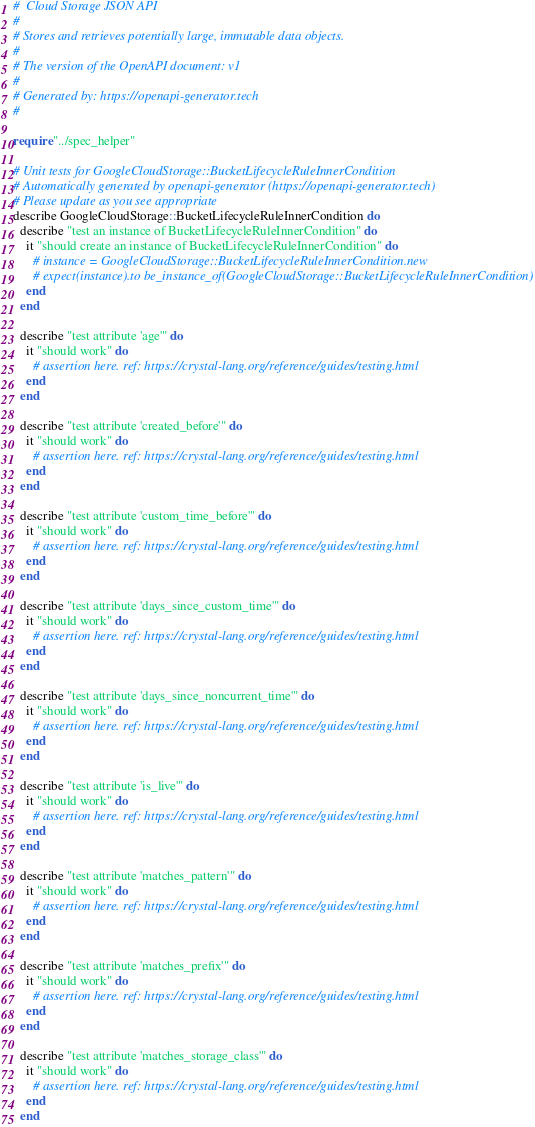Convert code to text. <code><loc_0><loc_0><loc_500><loc_500><_Crystal_>#  Cloud Storage JSON API
#
# Stores and retrieves potentially large, immutable data objects.
#
# The version of the OpenAPI document: v1
#
# Generated by: https://openapi-generator.tech
#

require "../spec_helper"

# Unit tests for GoogleCloudStorage::BucketLifecycleRuleInnerCondition
# Automatically generated by openapi-generator (https://openapi-generator.tech)
# Please update as you see appropriate
describe GoogleCloudStorage::BucketLifecycleRuleInnerCondition do
  describe "test an instance of BucketLifecycleRuleInnerCondition" do
    it "should create an instance of BucketLifecycleRuleInnerCondition" do
      # instance = GoogleCloudStorage::BucketLifecycleRuleInnerCondition.new
      # expect(instance).to be_instance_of(GoogleCloudStorage::BucketLifecycleRuleInnerCondition)
    end
  end

  describe "test attribute 'age'" do
    it "should work" do
      # assertion here. ref: https://crystal-lang.org/reference/guides/testing.html
    end
  end

  describe "test attribute 'created_before'" do
    it "should work" do
      # assertion here. ref: https://crystal-lang.org/reference/guides/testing.html
    end
  end

  describe "test attribute 'custom_time_before'" do
    it "should work" do
      # assertion here. ref: https://crystal-lang.org/reference/guides/testing.html
    end
  end

  describe "test attribute 'days_since_custom_time'" do
    it "should work" do
      # assertion here. ref: https://crystal-lang.org/reference/guides/testing.html
    end
  end

  describe "test attribute 'days_since_noncurrent_time'" do
    it "should work" do
      # assertion here. ref: https://crystal-lang.org/reference/guides/testing.html
    end
  end

  describe "test attribute 'is_live'" do
    it "should work" do
      # assertion here. ref: https://crystal-lang.org/reference/guides/testing.html
    end
  end

  describe "test attribute 'matches_pattern'" do
    it "should work" do
      # assertion here. ref: https://crystal-lang.org/reference/guides/testing.html
    end
  end

  describe "test attribute 'matches_prefix'" do
    it "should work" do
      # assertion here. ref: https://crystal-lang.org/reference/guides/testing.html
    end
  end

  describe "test attribute 'matches_storage_class'" do
    it "should work" do
      # assertion here. ref: https://crystal-lang.org/reference/guides/testing.html
    end
  end
</code> 